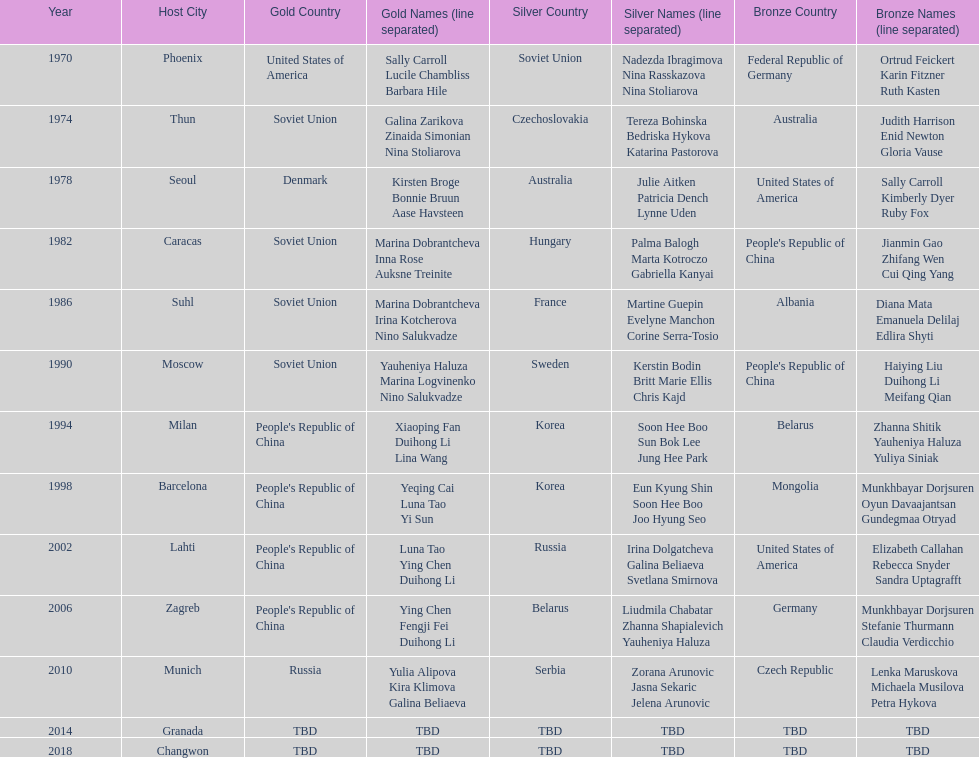Which country is listed the most under the silver column? Korea. 